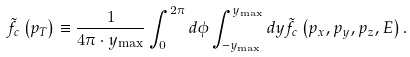<formula> <loc_0><loc_0><loc_500><loc_500>& \tilde { f } _ { c } \left ( p _ { T } \right ) \equiv \frac { 1 } { 4 \pi \cdot y _ { \max } } \int _ { 0 } ^ { 2 \pi } d \phi \int _ { - y _ { \max } } ^ { y _ { \max } } d y \tilde { f } _ { c } \left ( p _ { x } , p _ { y } , p _ { z } , E \right ) .</formula> 